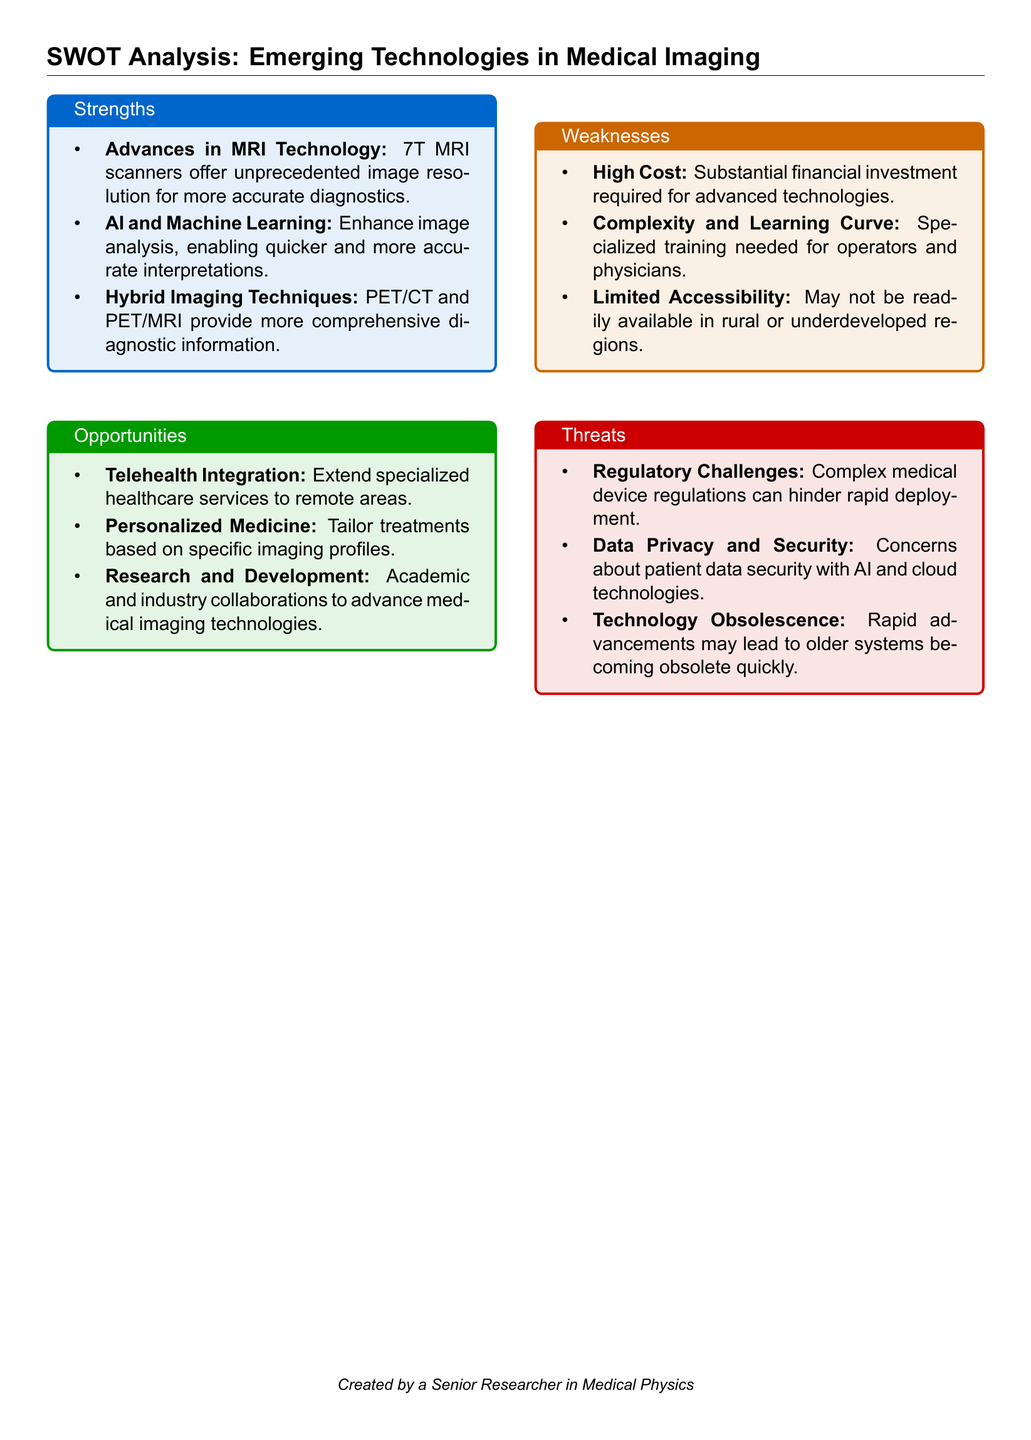What type of MRI scanners offer unprecedented image resolution? The document mentions that 7T MRI scanners provide unparalleled image resolution for accurate diagnostics.
Answer: 7T MRI scanners What technology enhances image analysis? The document states that AI and Machine Learning improve image analysis for quicker and more accurate interpretations.
Answer: AI and Machine Learning What is a significant weakness related to advanced technologies? The document identifies high cost as a major financial barrier for advanced medical imaging technologies.
Answer: High Cost What are hybrid imaging techniques mentioned in the document? The document refers to PET/CT and PET/MRI as hybrid imaging techniques providing comprehensive diagnostic information.
Answer: PET/CT and PET/MRI What opportunity is highlighted for extending healthcare services? The document lists telehealth integration as an opportunity to provide specialized healthcare services in remote areas.
Answer: Telehealth Integration Which challenge is associated with rapid deployment of new technologies? Regulatory challenges are specified in the document as a barrier to the quick deployment of emerging medical imaging technologies.
Answer: Regulatory Challenges What aspect of technology may lead to older systems becoming obsolete? The document describes technology obsolescence as a threat due to rapid advancements in medical imaging technologies.
Answer: Technology Obsolescence What concept is emphasized in the document for tailoring treatments? The document highlights personalized medicine as a key opportunity to tailor treatments based on specific imaging profiles.
Answer: Personalized Medicine 